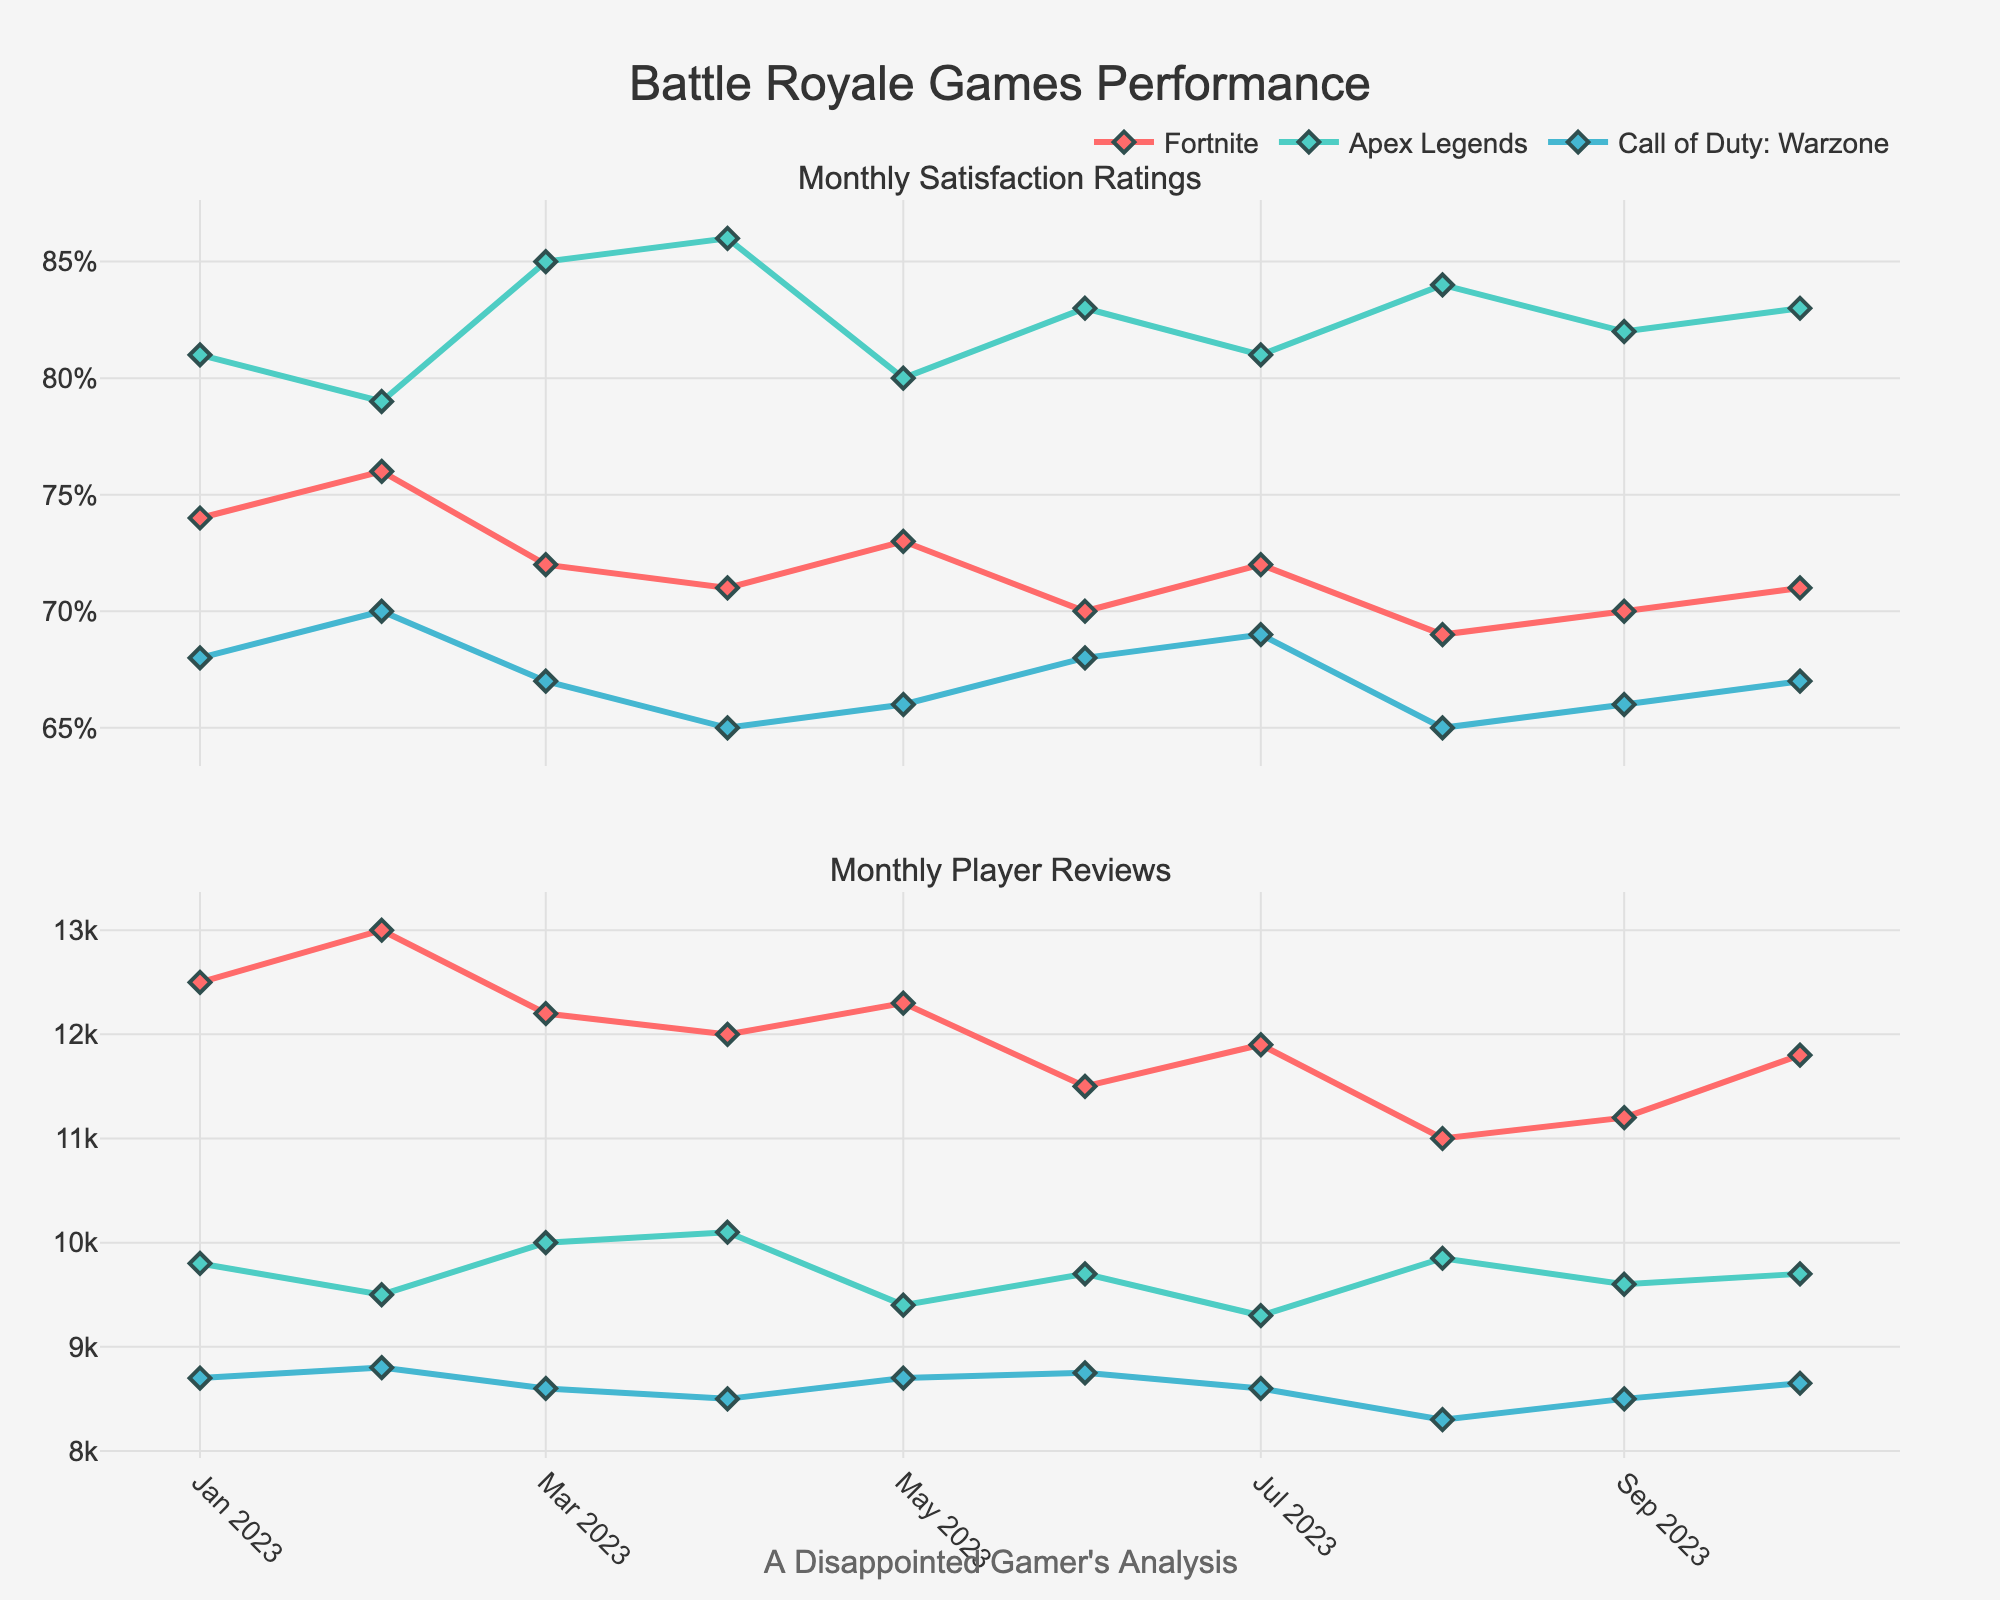What is the title of the figure? The title is displayed at the top of the figure, it summarizes what the figure is about.
Answer: Battle Royale Games Performance Which game had the highest satisfaction rating in October 2023? Look for the data points corresponding to October 2023 in the upper plot and compare the satisfaction ratings of each game.
Answer: Apex Legends How many player reviews did Fortnite receive in March 2023? Locate the data point for Fortnite in March 2023 in the bottom plot and read the value.
Answer: 12,200 Which game has the most fluctuations in satisfaction ratings over the months? Examine the lines in the upper plot for each game to identify which one shows the most variation (up and down movements).
Answer: Fortnite Comparing July 2023, which game had the lowest number of player reviews? Look at the data points in the bottom plot for July 2023 and identify the game with the smallest value.
Answer: Call of Duty: Warzone What is the difference in satisfaction ratings between Apex Legends and Fortnite in April 2023? Find the satisfaction ratings for Apex Legends and Fortnite in April 2023 in the upper plot, and then subtract the lower rating from the higher one.
Answer: 15% What is the average player review count for Call of Duty: Warzone from January to October 2023? Sum the player reviews for Call of Duty: Warzone from every month recorded and divide by the number of months (10).
Answer: 8,660 Did any game have a satisfaction rating above 85%? If so, which months and games? Inspect the upper plot for any data points above 85% and note the corresponding game and month.
Answer: Apex Legends in April and August 2023 Which month had the lowest overall satisfaction ratings across all games? Sum the satisfaction ratings for each game, month by month, and identify the month with the lowest total.
Answer: August 2023 Between May and June 2023, how did the number of player reviews for Apex Legends change? Compare the number of player reviews for Apex Legends in May and June 2023 by subtracting the May value from the June value.
Answer: Increased by 300 